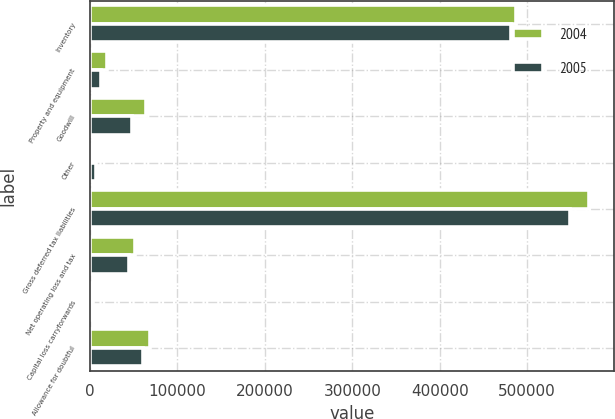Convert chart. <chart><loc_0><loc_0><loc_500><loc_500><stacked_bar_chart><ecel><fcel>Inventory<fcel>Property and equipment<fcel>Goodwill<fcel>Other<fcel>Gross deferred tax liabilities<fcel>Net operating loss and tax<fcel>Capital loss carryforwards<fcel>Allowance for doubtful<nl><fcel>2004<fcel>486791<fcel>19114<fcel>63904<fcel>936<fcel>570745<fcel>51075<fcel>3924<fcel>68892<nl><fcel>2005<fcel>481813<fcel>12517<fcel>47470<fcel>6708<fcel>548508<fcel>44977<fcel>1723<fcel>60160<nl></chart> 